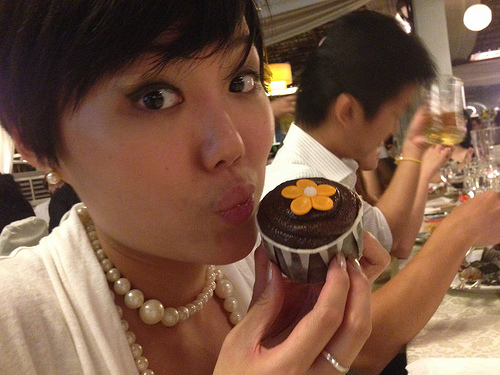Which color does the shirt that the man is wearing have? The shirt the man is wearing is white. 